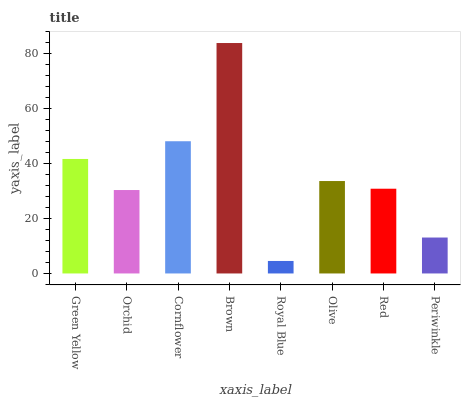Is Royal Blue the minimum?
Answer yes or no. Yes. Is Brown the maximum?
Answer yes or no. Yes. Is Orchid the minimum?
Answer yes or no. No. Is Orchid the maximum?
Answer yes or no. No. Is Green Yellow greater than Orchid?
Answer yes or no. Yes. Is Orchid less than Green Yellow?
Answer yes or no. Yes. Is Orchid greater than Green Yellow?
Answer yes or no. No. Is Green Yellow less than Orchid?
Answer yes or no. No. Is Olive the high median?
Answer yes or no. Yes. Is Red the low median?
Answer yes or no. Yes. Is Cornflower the high median?
Answer yes or no. No. Is Brown the low median?
Answer yes or no. No. 